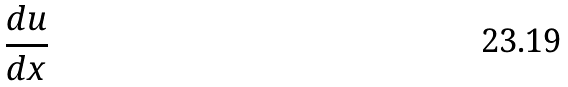Convert formula to latex. <formula><loc_0><loc_0><loc_500><loc_500>\frac { d u } { d x }</formula> 